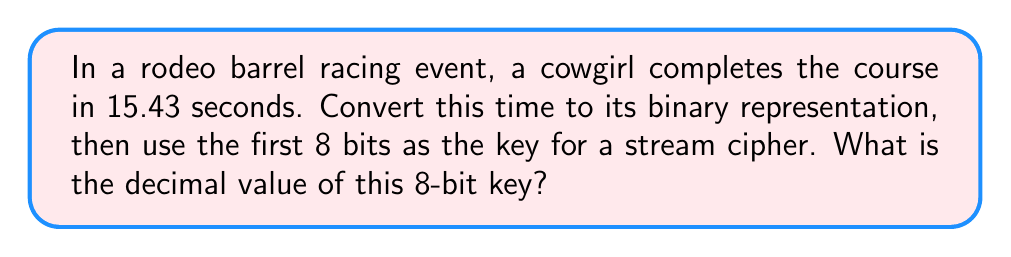Provide a solution to this math problem. Let's approach this step-by-step:

1) First, we need to convert 15.43 seconds to binary. We'll focus on the integer part (15) and the fractional part (0.43) separately.

2) Converting 15 to binary:
   $15 \div 2 = 7$ remainder $1$
   $7 \div 2 = 3$ remainder $1$
   $3 \div 2 = 1$ remainder $1$
   $1 \div 2 = 0$ remainder $1$
   
   Reading the remainders from bottom to top, we get: $15_{10} = 1111_2$

3) Converting 0.43 to binary:
   $0.43 \times 2 = 0.86$ (0)
   $0.86 \times 2 = 1.72$ (1)
   $0.72 \times 2 = 1.44$ (1)
   $0.44 \times 2 = 0.88$ (0)
   $0.88 \times 2 = 1.76$ (1)
   ...

   The fractional part in binary is $0.01101..._2$

4) Combining the integer and fractional parts:
   $15.43_{10} = 1111.01101..._2$

5) The first 8 bits of this binary representation are $11110110_2$

6) To convert this 8-bit binary number back to decimal:

   $1\times2^7 + 1\times2^6 + 1\times2^5 + 1\times2^4 + 0\times2^3 + 1\times2^2 + 1\times2^1 + 0\times2^0$
   
   $= 128 + 64 + 32 + 16 + 0 + 4 + 2 + 0 = 246$

Therefore, the decimal value of the 8-bit key is 246.
Answer: 246 